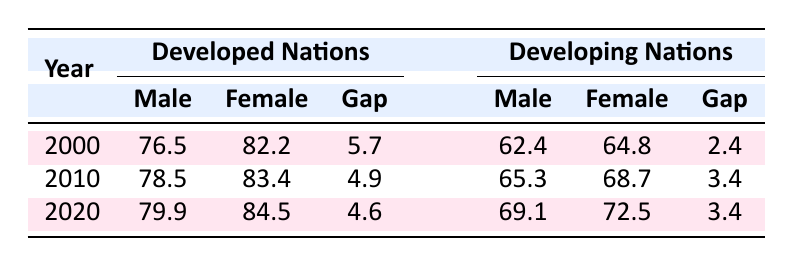What was the life expectancy for males in developed nations in 2010? According to the table, the life expectancy for males in developed nations in 2010 is explicitly listed as 78.5 years.
Answer: 78.5 What is the gap in life expectancy between males and females in developing nations for the year 2020? In the table, for developing nations in 2020, the life expectancy for males is 69.1 years and for females is 72.5 years. The gap is calculated as 72.5 - 69.1 = 3.4 years.
Answer: 3.4 Was the life expectancy for females in developed nations greater than that of males in the same year for all listed years? By looking at the table, for developed nations in each year—2000 (82.2 vs. 76.5), 2010 (83.4 vs. 78.5), and 2020 (84.5 vs. 79.9)—females always had a higher life expectancy than males. Therefore, the answer is true.
Answer: Yes What was the average life expectancy for males in developed nations over the years 2000, 2010, and 2020? The life expectancies for males are 76.5, 78.5, and 79.9 for the respective years. We sum these values (76.5 + 78.5 + 79.9 = 234.9) and divide by the number of years (3), yielding an average of 234.9 / 3 = 78.3 years.
Answer: 78.3 Did females in developing nations experience a larger increase in life expectancy from 2000 to 2020 than males? The life expectancy for females in developing nations increased from 64.8 in 2000 to 72.5 in 2020 (72.5 - 64.8 = 7.7 years). For males, it increased from 62.4 in 2000 to 69.1 in 2020 (69.1 - 62.4 = 6.7 years). Thus, females experienced a larger increase.
Answer: Yes What was the life expectancy for females in developed nations in 2000, and how does it compare to males in the same year? According to the table, females in developed nations had a life expectancy of 82.2 in 2000, while males had 76.5. The difference is 82.2 - 76.5 = 5.7 years, indicating females lived longer.
Answer: 82.2 (5.7 years more than males) How much did the gap between male and female life expectancy change in developed nations from 2000 to 2010? In 2000, the gap was 5.7 years, and in 2010 it decreased to 4.9 years. The change in gap is calculated by subtracting the 2010 gap from the 2000 gap (5.7 - 4.9 = 0.8 years), indicating a reduction of the gap.
Answer: 0.8 Which group experienced a greater overall life expectancy in the year 2020, males or females in developed nations? In 2020, males in developed nations had a life expectancy of 79.9 years, whereas females had 84.5 years. Comparing these figures shows females had a greater overall life expectancy in 2020.
Answer: Yes 